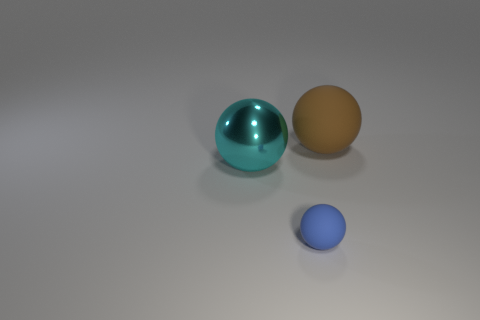Is the number of metallic things that are behind the big matte object greater than the number of large metal spheres that are on the left side of the metallic ball?
Keep it short and to the point. No. Is there a big red thing that has the same shape as the tiny blue rubber object?
Make the answer very short. No. There is a matte ball to the left of the big thing on the right side of the small object; what size is it?
Provide a short and direct response. Small. What is the size of the brown thing that is made of the same material as the tiny ball?
Provide a succinct answer. Large. Are there more yellow shiny objects than matte spheres?
Offer a very short reply. No. There is another sphere that is the same size as the cyan sphere; what is its material?
Ensure brevity in your answer.  Rubber. There is a matte ball that is in front of the cyan metallic sphere; is it the same size as the large cyan ball?
Keep it short and to the point. No. How many cylinders are tiny metallic objects or small rubber things?
Keep it short and to the point. 0. There is a large thing that is to the right of the blue matte object; what is its material?
Your response must be concise. Rubber. Is the number of small matte balls less than the number of large spheres?
Your answer should be very brief. Yes. 